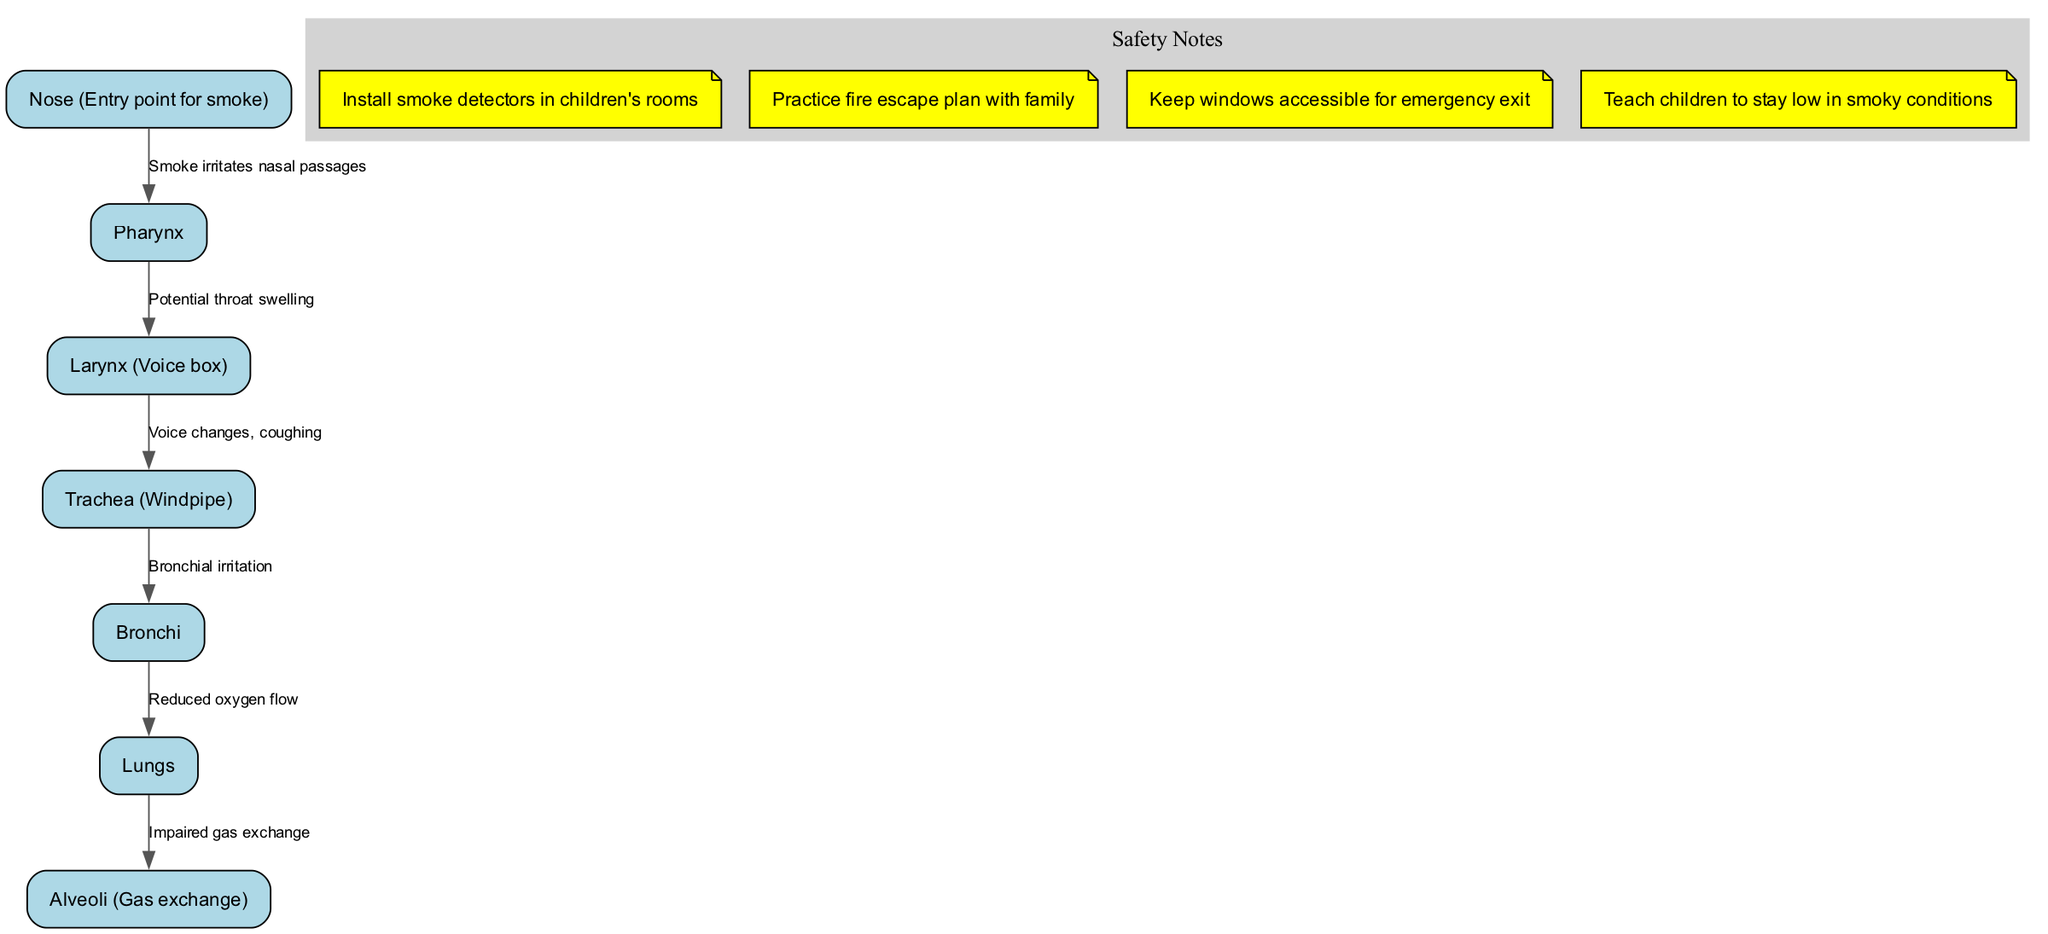What is the entry point for smoke in the respiratory system? The diagram indicates that the entry point for smoke is the "Nose." This is the first node listed in the diagram and is positioned at the top as the starting point.
Answer: Nose (Entry point for smoke) How many nodes are in this diagram? Counting the nodes listed in the diagram, there are seven nodes including the nose, pharynx, larynx, trachea, bronchi, lungs, and alveoli.
Answer: 7 What does smoke irritate as it enters the respiratory system? According to the diagram, smoke irritates the "nasal passages," which is represented as flowing from the "Nose" to "Pharynx."
Answer: nasal passages What is the impact of smoke on the lungs? The diagram illustrates that smoke leads to "Impaired gas exchange" in the alveoli, which directly affects the lungs' ability to function properly.
Answer: Impaired gas exchange What is one of the risks associated with the larynx due to smoke inhalation? The diagram shows that a potential risk associated with the larynx is "voice changes, coughing," demonstrating the negative effects on speech and respiratory health.
Answer: voice changes, coughing What safety note suggests a practice related to family safety? The safety note regarding family safety suggests to "Practice fire escape plan with family," emphasizing the importance of preparation in case of an emergency.
Answer: Practice fire escape plan with family What flows directly from the bronchi to the lungs? The diagram states that there is "Reduced oxygen flow" flowing from the bronchi directly into the lungs, indicating a critical function of inhaled air that is hindered by smoke.
Answer: Reduced oxygen flow How does smoke affect the alveoli? The diagram indicates that the presence of smoke leads to "Impaired gas exchange" in the alveoli, showing the adverse effects of smoke on the respiratory system's ability to exchange gases.
Answer: Impaired gas exchange 